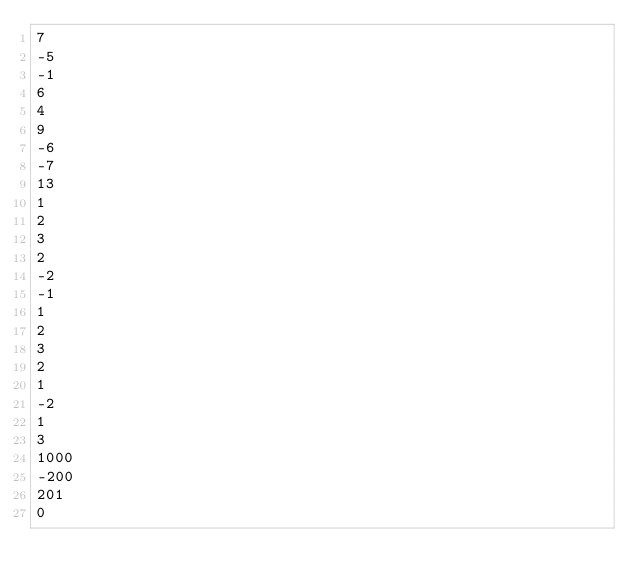Convert code to text. <code><loc_0><loc_0><loc_500><loc_500><_C_>7
-5
-1
6
4
9
-6
-7
13
1
2
3
2
-2
-1
1
2
3
2
1
-2
1
3
1000
-200
201
0</code> 